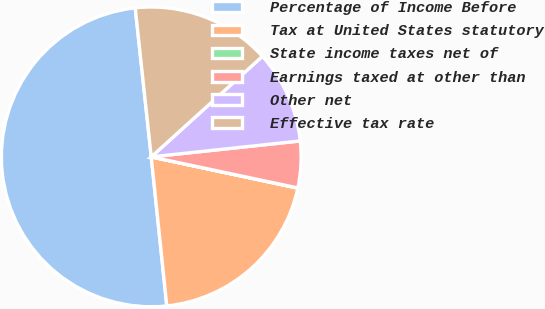Convert chart. <chart><loc_0><loc_0><loc_500><loc_500><pie_chart><fcel>Percentage of Income Before<fcel>Tax at United States statutory<fcel>State income taxes net of<fcel>Earnings taxed at other than<fcel>Other net<fcel>Effective tax rate<nl><fcel>49.95%<fcel>20.0%<fcel>0.02%<fcel>5.02%<fcel>10.01%<fcel>15.0%<nl></chart> 